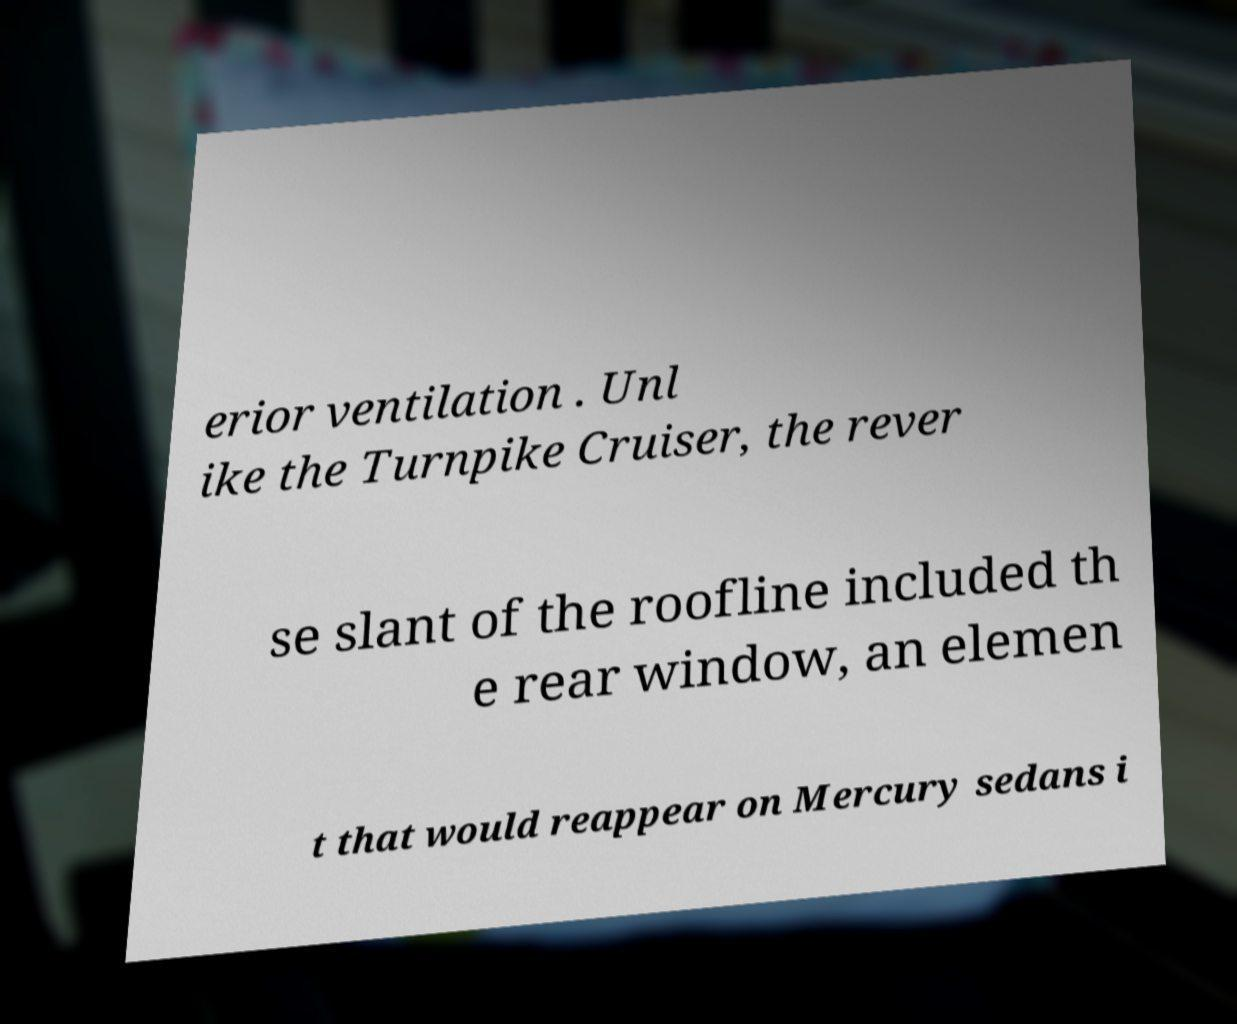For documentation purposes, I need the text within this image transcribed. Could you provide that? erior ventilation . Unl ike the Turnpike Cruiser, the rever se slant of the roofline included th e rear window, an elemen t that would reappear on Mercury sedans i 